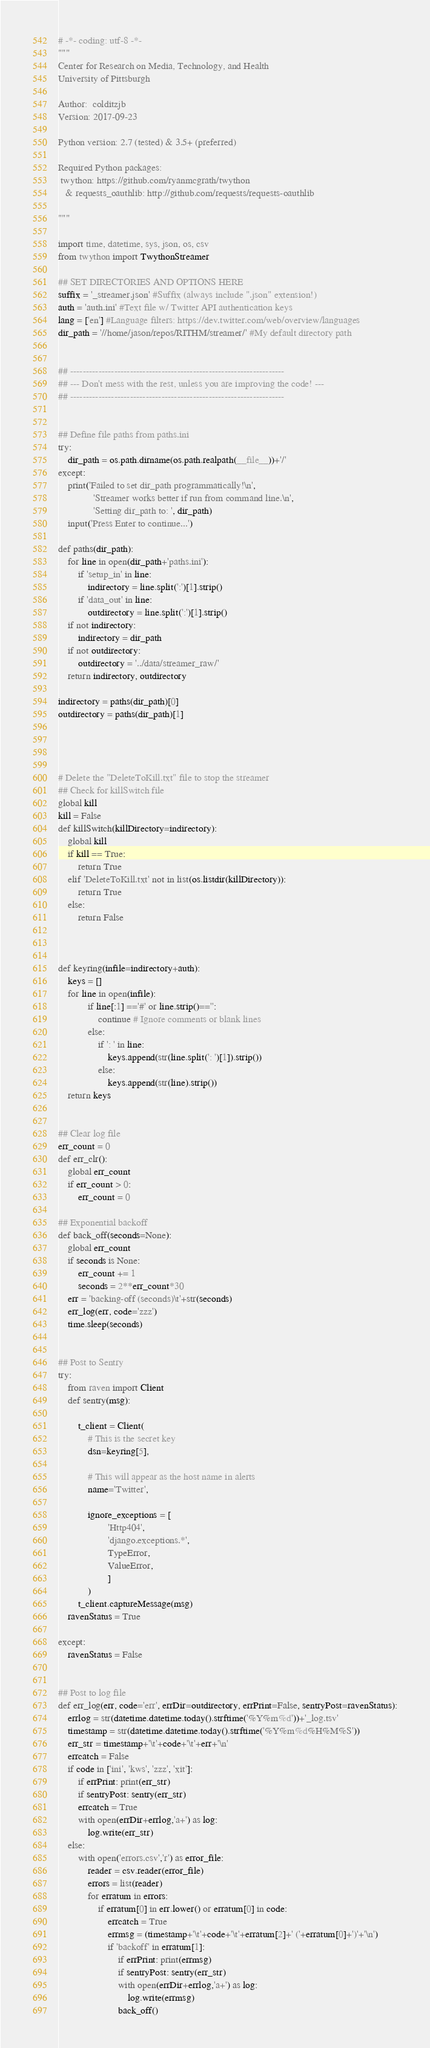<code> <loc_0><loc_0><loc_500><loc_500><_Python_># -*- coding: utf-8 -*-
"""
Center for Research on Media, Technology, and Health
University of Pittsburgh

Author:  colditzjb
Version: 2017-09-23

Python version: 2.7 (tested) & 3.5+ (preferred)

Required Python packages:
 twython: https://github.com/ryanmcgrath/twython
   & requests_oauthlib: http://github.com/requests/requests-oauthlib

"""

import time, datetime, sys, json, os, csv
from twython import TwythonStreamer

## SET DIRECTORIES AND OPTIONS HERE
suffix = '_streamer.json' #Suffix (always include ".json" extension!)
auth = 'auth.ini' #Text file w/ Twitter API authentication keys
lang = ['en'] #Language filters: https://dev.twitter.com/web/overview/languages
dir_path = '//home/jason/repos/RITHM/streamer/' #My default directory path


## --------------------------------------------------------------------
## --- Don't mess with the rest, unless you are improving the code! ---
## --------------------------------------------------------------------


## Define file paths from paths.ini
try: 
    dir_path = os.path.dirname(os.path.realpath(__file__))+'/'
except: 
    print('Failed to set dir_path programmatically!\n',
              'Streamer works better if run from command line.\n',
              'Setting dir_path to: ', dir_path)
    input('Press Enter to continue...')
    
def paths(dir_path):
    for line in open(dir_path+'paths.ini'):
        if 'setup_in' in line:
            indirectory = line.split(':')[1].strip()
        if 'data_out' in line:
            outdirectory = line.split(':')[1].strip()
    if not indirectory:
        indirectory = dir_path
    if not outdirectory:
        outdirectory = '../data/streamer_raw/'
    return indirectory, outdirectory

indirectory = paths(dir_path)[0]
outdirectory = paths(dir_path)[1]




# Delete the "DeleteToKill.txt" file to stop the streamer 
## Check for killSwitch file
global kill
kill = False
def killSwitch(killDirectory=indirectory):
    global kill
    if kill == True:
        return True
    elif 'DeleteToKill.txt' not in list(os.listdir(killDirectory)):
        return True
    else:
        return False



def keyring(infile=indirectory+auth):
    keys = []
    for line in open(infile):
            if line[:1] =='#' or line.strip()=='':
                continue # Ignore comments or blank lines 
            else:
                if ': ' in line:
                    keys.append(str(line.split(': ')[1]).strip())
                else:
                    keys.append(str(line).strip())
    return keys


## Clear log file
err_count = 0
def err_clr():
    global err_count
    if err_count > 0:
        err_count = 0

## Exponential backoff
def back_off(seconds=None):
    global err_count 
    if seconds is None:
        err_count += 1
        seconds = 2**err_count*30
    err = 'backing-off (seconds)\t'+str(seconds)
    err_log(err, code='zzz')
    time.sleep(seconds)


## Post to Sentry
try:
    from raven import Client
    def sentry(msg):
    
        t_client = Client(
            # This is the secret key
            dsn=keyring[5],
            
            # This will appear as the host name in alerts
            name='Twitter',
            
            ignore_exceptions = [
                    'Http404',
                    'django.exceptions.*',
                    TypeError,
                    ValueError,
                    ]
            )
        t_client.captureMessage(msg)
    ravenStatus = True

except:
    ravenStatus = False


## Post to log file 
def err_log(err, code='err', errDir=outdirectory, errPrint=False, sentryPost=ravenStatus):
    errlog = str(datetime.datetime.today().strftime('%Y%m%d'))+'_log.tsv'
    timestamp = str(datetime.datetime.today().strftime('%Y%m%d%H%M%S'))
    err_str = timestamp+'\t'+code+'\t'+err+'\n'
    errcatch = False
    if code in ['ini', 'kws', 'zzz', 'xit']:
        if errPrint: print(err_str)
        if sentryPost: sentry(err_str)
        errcatch = True
        with open(errDir+errlog,'a+') as log:
            log.write(err_str)
    else:
        with open('errors.csv','r') as error_file:
            reader = csv.reader(error_file)
            errors = list(reader)
            for erratum in errors:
                if erratum[0] in err.lower() or erratum[0] in code:
                    errcatch = True
                    errmsg = (timestamp+'\t'+code+'\t'+erratum[2]+' ('+erratum[0]+')'+'\n')
                    if 'backoff' in erratum[1]:
                        if errPrint: print(errmsg)
                        if sentryPost: sentry(err_str)
                        with open(errDir+errlog,'a+') as log:
                            log.write(errmsg)
                        back_off()</code> 